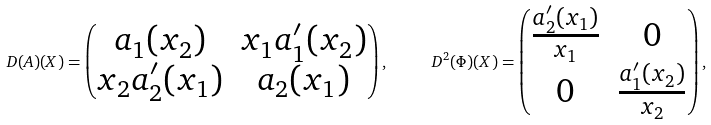<formula> <loc_0><loc_0><loc_500><loc_500>\ D ( A ) ( X ) = \begin{pmatrix} a _ { 1 } ( x _ { 2 } ) & x _ { 1 } a _ { 1 } ^ { \prime } ( x _ { 2 } ) \\ x _ { 2 } a _ { 2 } ^ { \prime } ( x _ { 1 } ) & a _ { 2 } ( x _ { 1 } ) \end{pmatrix} , \quad \ D ^ { 2 } ( \Phi ) ( X ) = \begin{pmatrix} \frac { a _ { 2 } ^ { \prime } ( x _ { 1 } ) } { x _ { 1 } } & 0 \\ 0 & \frac { a _ { 1 } ^ { \prime } ( x _ { 2 } ) } { x _ { 2 } } \end{pmatrix} ,</formula> 